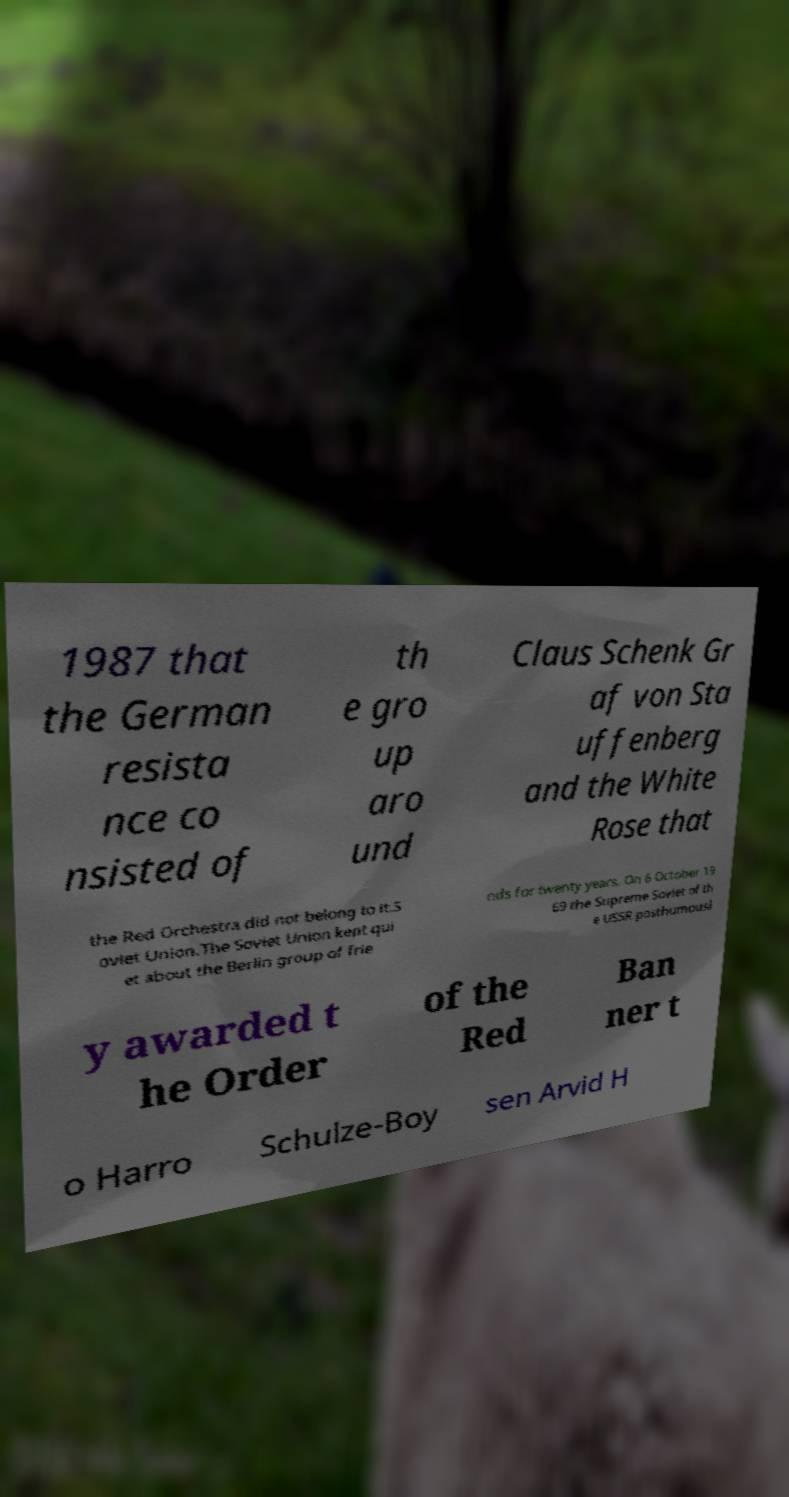I need the written content from this picture converted into text. Can you do that? 1987 that the German resista nce co nsisted of th e gro up aro und Claus Schenk Gr af von Sta uffenberg and the White Rose that the Red Orchestra did not belong to it.S oviet Union.The Soviet Union kept qui et about the Berlin group of frie nds for twenty years. On 6 October 19 69 the Supreme Soviet of th e USSR posthumousl y awarded t he Order of the Red Ban ner t o Harro Schulze-Boy sen Arvid H 